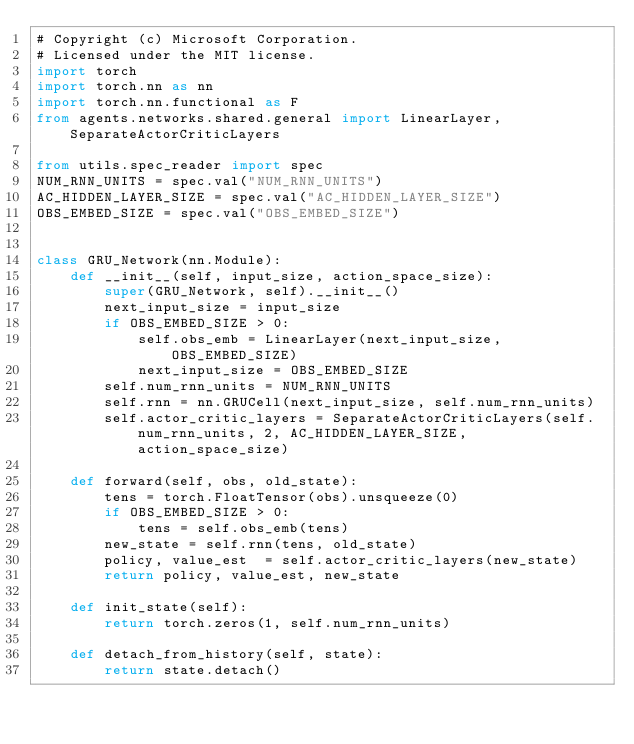Convert code to text. <code><loc_0><loc_0><loc_500><loc_500><_Python_># Copyright (c) Microsoft Corporation.
# Licensed under the MIT license.
import torch
import torch.nn as nn
import torch.nn.functional as F
from agents.networks.shared.general import LinearLayer, SeparateActorCriticLayers

from utils.spec_reader import spec
NUM_RNN_UNITS = spec.val("NUM_RNN_UNITS")
AC_HIDDEN_LAYER_SIZE = spec.val("AC_HIDDEN_LAYER_SIZE")
OBS_EMBED_SIZE = spec.val("OBS_EMBED_SIZE")


class GRU_Network(nn.Module):
    def __init__(self, input_size, action_space_size):
        super(GRU_Network, self).__init__()
        next_input_size = input_size
        if OBS_EMBED_SIZE > 0:
            self.obs_emb = LinearLayer(next_input_size, OBS_EMBED_SIZE)
            next_input_size = OBS_EMBED_SIZE
        self.num_rnn_units = NUM_RNN_UNITS
        self.rnn = nn.GRUCell(next_input_size, self.num_rnn_units)
        self.actor_critic_layers = SeparateActorCriticLayers(self.num_rnn_units, 2, AC_HIDDEN_LAYER_SIZE, action_space_size)

    def forward(self, obs, old_state):
        tens = torch.FloatTensor(obs).unsqueeze(0)
        if OBS_EMBED_SIZE > 0:
            tens = self.obs_emb(tens)
        new_state = self.rnn(tens, old_state)
        policy, value_est  = self.actor_critic_layers(new_state)
        return policy, value_est, new_state

    def init_state(self):
        return torch.zeros(1, self.num_rnn_units)

    def detach_from_history(self, state):
        return state.detach()
</code> 